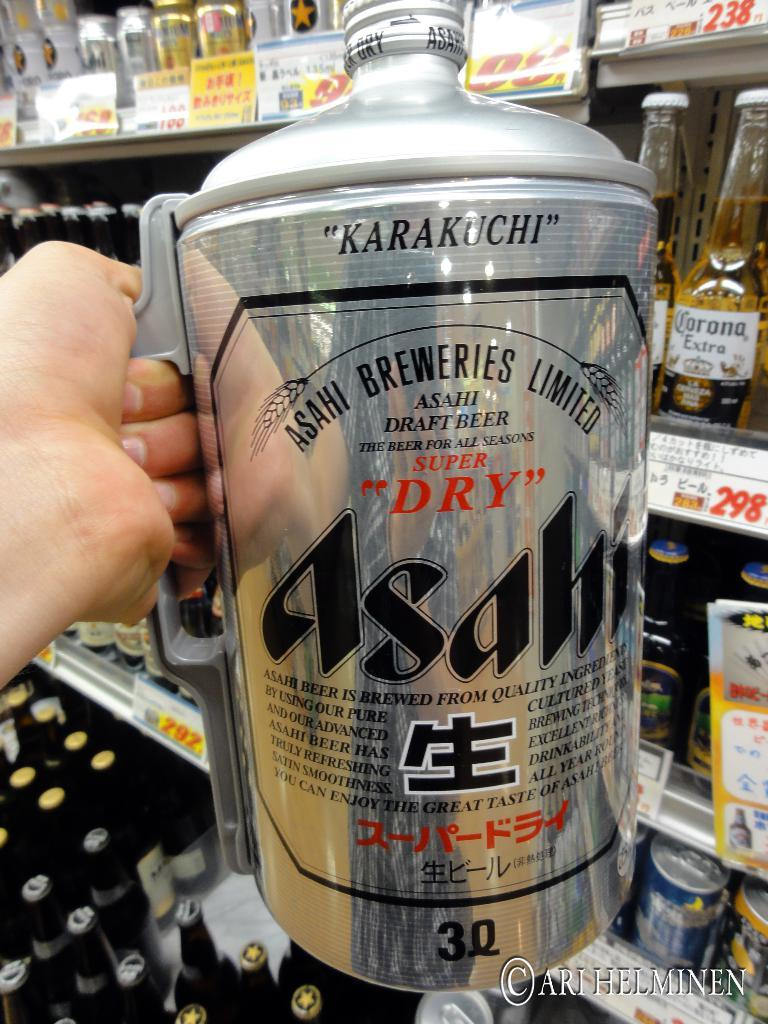<image>
Present a compact description of the photo's key features. A large can of beer that says Karakuchi at the top. 